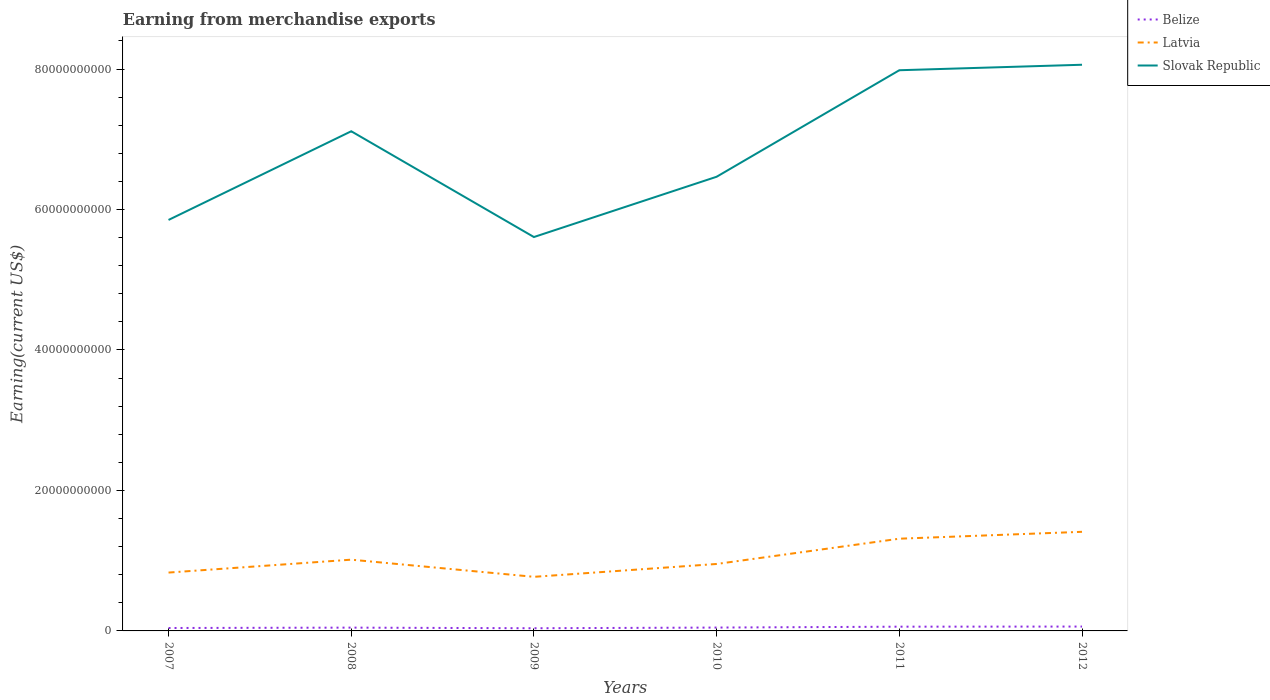How many different coloured lines are there?
Your answer should be very brief. 3. Across all years, what is the maximum amount earned from merchandise exports in Slovak Republic?
Offer a very short reply. 5.61e+1. In which year was the amount earned from merchandise exports in Slovak Republic maximum?
Your answer should be very brief. 2009. What is the total amount earned from merchandise exports in Latvia in the graph?
Your response must be concise. -6.41e+09. What is the difference between the highest and the second highest amount earned from merchandise exports in Slovak Republic?
Your response must be concise. 2.45e+1. How many lines are there?
Make the answer very short. 3. How many years are there in the graph?
Your answer should be very brief. 6. Does the graph contain grids?
Your response must be concise. No. How many legend labels are there?
Provide a short and direct response. 3. What is the title of the graph?
Ensure brevity in your answer.  Earning from merchandise exports. Does "Pakistan" appear as one of the legend labels in the graph?
Your response must be concise. No. What is the label or title of the X-axis?
Your response must be concise. Years. What is the label or title of the Y-axis?
Keep it short and to the point. Earning(current US$). What is the Earning(current US$) of Belize in 2007?
Your response must be concise. 4.16e+08. What is the Earning(current US$) of Latvia in 2007?
Offer a terse response. 8.31e+09. What is the Earning(current US$) of Slovak Republic in 2007?
Your answer should be compact. 5.85e+1. What is the Earning(current US$) of Belize in 2008?
Your answer should be very brief. 4.69e+08. What is the Earning(current US$) in Latvia in 2008?
Your response must be concise. 1.01e+1. What is the Earning(current US$) in Slovak Republic in 2008?
Give a very brief answer. 7.11e+1. What is the Earning(current US$) of Belize in 2009?
Your answer should be very brief. 3.81e+08. What is the Earning(current US$) of Latvia in 2009?
Provide a short and direct response. 7.70e+09. What is the Earning(current US$) in Slovak Republic in 2009?
Keep it short and to the point. 5.61e+1. What is the Earning(current US$) in Belize in 2010?
Give a very brief answer. 4.78e+08. What is the Earning(current US$) of Latvia in 2010?
Ensure brevity in your answer.  9.53e+09. What is the Earning(current US$) of Slovak Republic in 2010?
Your answer should be very brief. 6.47e+1. What is the Earning(current US$) of Belize in 2011?
Provide a short and direct response. 6.04e+08. What is the Earning(current US$) of Latvia in 2011?
Your response must be concise. 1.31e+1. What is the Earning(current US$) in Slovak Republic in 2011?
Make the answer very short. 7.98e+1. What is the Earning(current US$) of Belize in 2012?
Keep it short and to the point. 6.22e+08. What is the Earning(current US$) of Latvia in 2012?
Make the answer very short. 1.41e+1. What is the Earning(current US$) in Slovak Republic in 2012?
Offer a very short reply. 8.06e+1. Across all years, what is the maximum Earning(current US$) of Belize?
Keep it short and to the point. 6.22e+08. Across all years, what is the maximum Earning(current US$) in Latvia?
Your response must be concise. 1.41e+1. Across all years, what is the maximum Earning(current US$) of Slovak Republic?
Ensure brevity in your answer.  8.06e+1. Across all years, what is the minimum Earning(current US$) of Belize?
Give a very brief answer. 3.81e+08. Across all years, what is the minimum Earning(current US$) in Latvia?
Provide a short and direct response. 7.70e+09. Across all years, what is the minimum Earning(current US$) of Slovak Republic?
Your answer should be compact. 5.61e+1. What is the total Earning(current US$) of Belize in the graph?
Provide a succinct answer. 2.97e+09. What is the total Earning(current US$) of Latvia in the graph?
Your response must be concise. 6.29e+1. What is the total Earning(current US$) of Slovak Republic in the graph?
Offer a very short reply. 4.11e+11. What is the difference between the Earning(current US$) in Belize in 2007 and that in 2008?
Provide a succinct answer. -5.28e+07. What is the difference between the Earning(current US$) in Latvia in 2007 and that in 2008?
Keep it short and to the point. -1.84e+09. What is the difference between the Earning(current US$) in Slovak Republic in 2007 and that in 2008?
Provide a succinct answer. -1.26e+1. What is the difference between the Earning(current US$) of Belize in 2007 and that in 2009?
Your response must be concise. 3.54e+07. What is the difference between the Earning(current US$) in Latvia in 2007 and that in 2009?
Keep it short and to the point. 6.06e+08. What is the difference between the Earning(current US$) in Slovak Republic in 2007 and that in 2009?
Offer a very short reply. 2.43e+09. What is the difference between the Earning(current US$) in Belize in 2007 and that in 2010?
Make the answer very short. -6.19e+07. What is the difference between the Earning(current US$) of Latvia in 2007 and that in 2010?
Your response must be concise. -1.22e+09. What is the difference between the Earning(current US$) in Slovak Republic in 2007 and that in 2010?
Offer a very short reply. -6.15e+09. What is the difference between the Earning(current US$) in Belize in 2007 and that in 2011?
Keep it short and to the point. -1.87e+08. What is the difference between the Earning(current US$) in Latvia in 2007 and that in 2011?
Your answer should be very brief. -4.82e+09. What is the difference between the Earning(current US$) in Slovak Republic in 2007 and that in 2011?
Your response must be concise. -2.13e+1. What is the difference between the Earning(current US$) of Belize in 2007 and that in 2012?
Keep it short and to the point. -2.05e+08. What is the difference between the Earning(current US$) in Latvia in 2007 and that in 2012?
Give a very brief answer. -5.80e+09. What is the difference between the Earning(current US$) in Slovak Republic in 2007 and that in 2012?
Make the answer very short. -2.21e+1. What is the difference between the Earning(current US$) in Belize in 2008 and that in 2009?
Provide a short and direct response. 8.82e+07. What is the difference between the Earning(current US$) in Latvia in 2008 and that in 2009?
Provide a succinct answer. 2.44e+09. What is the difference between the Earning(current US$) of Slovak Republic in 2008 and that in 2009?
Your answer should be very brief. 1.51e+1. What is the difference between the Earning(current US$) of Belize in 2008 and that in 2010?
Give a very brief answer. -9.06e+06. What is the difference between the Earning(current US$) of Latvia in 2008 and that in 2010?
Offer a terse response. 6.12e+08. What is the difference between the Earning(current US$) in Slovak Republic in 2008 and that in 2010?
Make the answer very short. 6.48e+09. What is the difference between the Earning(current US$) of Belize in 2008 and that in 2011?
Keep it short and to the point. -1.34e+08. What is the difference between the Earning(current US$) in Latvia in 2008 and that in 2011?
Keep it short and to the point. -2.99e+09. What is the difference between the Earning(current US$) in Slovak Republic in 2008 and that in 2011?
Offer a terse response. -8.69e+09. What is the difference between the Earning(current US$) of Belize in 2008 and that in 2012?
Provide a succinct answer. -1.52e+08. What is the difference between the Earning(current US$) of Latvia in 2008 and that in 2012?
Offer a very short reply. -3.97e+09. What is the difference between the Earning(current US$) in Slovak Republic in 2008 and that in 2012?
Provide a succinct answer. -9.47e+09. What is the difference between the Earning(current US$) of Belize in 2009 and that in 2010?
Provide a short and direct response. -9.72e+07. What is the difference between the Earning(current US$) of Latvia in 2009 and that in 2010?
Offer a terse response. -1.83e+09. What is the difference between the Earning(current US$) in Slovak Republic in 2009 and that in 2010?
Provide a succinct answer. -8.58e+09. What is the difference between the Earning(current US$) in Belize in 2009 and that in 2011?
Your answer should be compact. -2.23e+08. What is the difference between the Earning(current US$) of Latvia in 2009 and that in 2011?
Give a very brief answer. -5.43e+09. What is the difference between the Earning(current US$) in Slovak Republic in 2009 and that in 2011?
Give a very brief answer. -2.37e+1. What is the difference between the Earning(current US$) of Belize in 2009 and that in 2012?
Your answer should be compact. -2.41e+08. What is the difference between the Earning(current US$) of Latvia in 2009 and that in 2012?
Give a very brief answer. -6.41e+09. What is the difference between the Earning(current US$) of Slovak Republic in 2009 and that in 2012?
Give a very brief answer. -2.45e+1. What is the difference between the Earning(current US$) of Belize in 2010 and that in 2011?
Keep it short and to the point. -1.25e+08. What is the difference between the Earning(current US$) of Latvia in 2010 and that in 2011?
Make the answer very short. -3.60e+09. What is the difference between the Earning(current US$) in Slovak Republic in 2010 and that in 2011?
Keep it short and to the point. -1.52e+1. What is the difference between the Earning(current US$) of Belize in 2010 and that in 2012?
Give a very brief answer. -1.43e+08. What is the difference between the Earning(current US$) in Latvia in 2010 and that in 2012?
Make the answer very short. -4.58e+09. What is the difference between the Earning(current US$) of Slovak Republic in 2010 and that in 2012?
Offer a very short reply. -1.59e+1. What is the difference between the Earning(current US$) of Belize in 2011 and that in 2012?
Provide a short and direct response. -1.80e+07. What is the difference between the Earning(current US$) in Latvia in 2011 and that in 2012?
Your response must be concise. -9.81e+08. What is the difference between the Earning(current US$) in Slovak Republic in 2011 and that in 2012?
Your answer should be compact. -7.81e+08. What is the difference between the Earning(current US$) of Belize in 2007 and the Earning(current US$) of Latvia in 2008?
Provide a short and direct response. -9.73e+09. What is the difference between the Earning(current US$) in Belize in 2007 and the Earning(current US$) in Slovak Republic in 2008?
Ensure brevity in your answer.  -7.07e+1. What is the difference between the Earning(current US$) in Latvia in 2007 and the Earning(current US$) in Slovak Republic in 2008?
Ensure brevity in your answer.  -6.28e+1. What is the difference between the Earning(current US$) of Belize in 2007 and the Earning(current US$) of Latvia in 2009?
Your answer should be compact. -7.29e+09. What is the difference between the Earning(current US$) in Belize in 2007 and the Earning(current US$) in Slovak Republic in 2009?
Make the answer very short. -5.57e+1. What is the difference between the Earning(current US$) of Latvia in 2007 and the Earning(current US$) of Slovak Republic in 2009?
Give a very brief answer. -4.78e+1. What is the difference between the Earning(current US$) of Belize in 2007 and the Earning(current US$) of Latvia in 2010?
Provide a short and direct response. -9.12e+09. What is the difference between the Earning(current US$) of Belize in 2007 and the Earning(current US$) of Slovak Republic in 2010?
Provide a short and direct response. -6.42e+1. What is the difference between the Earning(current US$) in Latvia in 2007 and the Earning(current US$) in Slovak Republic in 2010?
Provide a short and direct response. -5.64e+1. What is the difference between the Earning(current US$) in Belize in 2007 and the Earning(current US$) in Latvia in 2011?
Offer a very short reply. -1.27e+1. What is the difference between the Earning(current US$) in Belize in 2007 and the Earning(current US$) in Slovak Republic in 2011?
Give a very brief answer. -7.94e+1. What is the difference between the Earning(current US$) of Latvia in 2007 and the Earning(current US$) of Slovak Republic in 2011?
Keep it short and to the point. -7.15e+1. What is the difference between the Earning(current US$) of Belize in 2007 and the Earning(current US$) of Latvia in 2012?
Provide a succinct answer. -1.37e+1. What is the difference between the Earning(current US$) of Belize in 2007 and the Earning(current US$) of Slovak Republic in 2012?
Provide a short and direct response. -8.02e+1. What is the difference between the Earning(current US$) in Latvia in 2007 and the Earning(current US$) in Slovak Republic in 2012?
Your response must be concise. -7.23e+1. What is the difference between the Earning(current US$) in Belize in 2008 and the Earning(current US$) in Latvia in 2009?
Your answer should be very brief. -7.23e+09. What is the difference between the Earning(current US$) of Belize in 2008 and the Earning(current US$) of Slovak Republic in 2009?
Your answer should be very brief. -5.56e+1. What is the difference between the Earning(current US$) of Latvia in 2008 and the Earning(current US$) of Slovak Republic in 2009?
Your answer should be compact. -4.59e+1. What is the difference between the Earning(current US$) of Belize in 2008 and the Earning(current US$) of Latvia in 2010?
Your response must be concise. -9.06e+09. What is the difference between the Earning(current US$) of Belize in 2008 and the Earning(current US$) of Slovak Republic in 2010?
Ensure brevity in your answer.  -6.42e+1. What is the difference between the Earning(current US$) of Latvia in 2008 and the Earning(current US$) of Slovak Republic in 2010?
Your answer should be compact. -5.45e+1. What is the difference between the Earning(current US$) of Belize in 2008 and the Earning(current US$) of Latvia in 2011?
Make the answer very short. -1.27e+1. What is the difference between the Earning(current US$) of Belize in 2008 and the Earning(current US$) of Slovak Republic in 2011?
Your answer should be very brief. -7.94e+1. What is the difference between the Earning(current US$) of Latvia in 2008 and the Earning(current US$) of Slovak Republic in 2011?
Make the answer very short. -6.97e+1. What is the difference between the Earning(current US$) in Belize in 2008 and the Earning(current US$) in Latvia in 2012?
Make the answer very short. -1.36e+1. What is the difference between the Earning(current US$) in Belize in 2008 and the Earning(current US$) in Slovak Republic in 2012?
Keep it short and to the point. -8.01e+1. What is the difference between the Earning(current US$) in Latvia in 2008 and the Earning(current US$) in Slovak Republic in 2012?
Provide a short and direct response. -7.05e+1. What is the difference between the Earning(current US$) of Belize in 2009 and the Earning(current US$) of Latvia in 2010?
Provide a succinct answer. -9.15e+09. What is the difference between the Earning(current US$) in Belize in 2009 and the Earning(current US$) in Slovak Republic in 2010?
Make the answer very short. -6.43e+1. What is the difference between the Earning(current US$) of Latvia in 2009 and the Earning(current US$) of Slovak Republic in 2010?
Give a very brief answer. -5.70e+1. What is the difference between the Earning(current US$) of Belize in 2009 and the Earning(current US$) of Latvia in 2011?
Provide a succinct answer. -1.27e+1. What is the difference between the Earning(current US$) in Belize in 2009 and the Earning(current US$) in Slovak Republic in 2011?
Offer a very short reply. -7.94e+1. What is the difference between the Earning(current US$) of Latvia in 2009 and the Earning(current US$) of Slovak Republic in 2011?
Your answer should be very brief. -7.21e+1. What is the difference between the Earning(current US$) of Belize in 2009 and the Earning(current US$) of Latvia in 2012?
Offer a very short reply. -1.37e+1. What is the difference between the Earning(current US$) in Belize in 2009 and the Earning(current US$) in Slovak Republic in 2012?
Ensure brevity in your answer.  -8.02e+1. What is the difference between the Earning(current US$) of Latvia in 2009 and the Earning(current US$) of Slovak Republic in 2012?
Provide a short and direct response. -7.29e+1. What is the difference between the Earning(current US$) in Belize in 2010 and the Earning(current US$) in Latvia in 2011?
Keep it short and to the point. -1.27e+1. What is the difference between the Earning(current US$) of Belize in 2010 and the Earning(current US$) of Slovak Republic in 2011?
Make the answer very short. -7.94e+1. What is the difference between the Earning(current US$) of Latvia in 2010 and the Earning(current US$) of Slovak Republic in 2011?
Offer a very short reply. -7.03e+1. What is the difference between the Earning(current US$) in Belize in 2010 and the Earning(current US$) in Latvia in 2012?
Your answer should be very brief. -1.36e+1. What is the difference between the Earning(current US$) in Belize in 2010 and the Earning(current US$) in Slovak Republic in 2012?
Give a very brief answer. -8.01e+1. What is the difference between the Earning(current US$) of Latvia in 2010 and the Earning(current US$) of Slovak Republic in 2012?
Your answer should be very brief. -7.11e+1. What is the difference between the Earning(current US$) of Belize in 2011 and the Earning(current US$) of Latvia in 2012?
Make the answer very short. -1.35e+1. What is the difference between the Earning(current US$) of Belize in 2011 and the Earning(current US$) of Slovak Republic in 2012?
Provide a succinct answer. -8.00e+1. What is the difference between the Earning(current US$) in Latvia in 2011 and the Earning(current US$) in Slovak Republic in 2012?
Give a very brief answer. -6.75e+1. What is the average Earning(current US$) in Belize per year?
Your answer should be compact. 4.95e+08. What is the average Earning(current US$) of Latvia per year?
Your response must be concise. 1.05e+1. What is the average Earning(current US$) in Slovak Republic per year?
Provide a succinct answer. 6.85e+1. In the year 2007, what is the difference between the Earning(current US$) of Belize and Earning(current US$) of Latvia?
Keep it short and to the point. -7.89e+09. In the year 2007, what is the difference between the Earning(current US$) of Belize and Earning(current US$) of Slovak Republic?
Provide a short and direct response. -5.81e+1. In the year 2007, what is the difference between the Earning(current US$) of Latvia and Earning(current US$) of Slovak Republic?
Your answer should be compact. -5.02e+1. In the year 2008, what is the difference between the Earning(current US$) of Belize and Earning(current US$) of Latvia?
Offer a terse response. -9.68e+09. In the year 2008, what is the difference between the Earning(current US$) of Belize and Earning(current US$) of Slovak Republic?
Your response must be concise. -7.07e+1. In the year 2008, what is the difference between the Earning(current US$) of Latvia and Earning(current US$) of Slovak Republic?
Your answer should be compact. -6.10e+1. In the year 2009, what is the difference between the Earning(current US$) in Belize and Earning(current US$) in Latvia?
Keep it short and to the point. -7.32e+09. In the year 2009, what is the difference between the Earning(current US$) of Belize and Earning(current US$) of Slovak Republic?
Your answer should be very brief. -5.57e+1. In the year 2009, what is the difference between the Earning(current US$) of Latvia and Earning(current US$) of Slovak Republic?
Provide a short and direct response. -4.84e+1. In the year 2010, what is the difference between the Earning(current US$) in Belize and Earning(current US$) in Latvia?
Keep it short and to the point. -9.05e+09. In the year 2010, what is the difference between the Earning(current US$) in Belize and Earning(current US$) in Slovak Republic?
Keep it short and to the point. -6.42e+1. In the year 2010, what is the difference between the Earning(current US$) of Latvia and Earning(current US$) of Slovak Republic?
Your answer should be compact. -5.51e+1. In the year 2011, what is the difference between the Earning(current US$) of Belize and Earning(current US$) of Latvia?
Provide a short and direct response. -1.25e+1. In the year 2011, what is the difference between the Earning(current US$) in Belize and Earning(current US$) in Slovak Republic?
Make the answer very short. -7.92e+1. In the year 2011, what is the difference between the Earning(current US$) of Latvia and Earning(current US$) of Slovak Republic?
Keep it short and to the point. -6.67e+1. In the year 2012, what is the difference between the Earning(current US$) of Belize and Earning(current US$) of Latvia?
Your answer should be very brief. -1.35e+1. In the year 2012, what is the difference between the Earning(current US$) of Belize and Earning(current US$) of Slovak Republic?
Give a very brief answer. -8.00e+1. In the year 2012, what is the difference between the Earning(current US$) of Latvia and Earning(current US$) of Slovak Republic?
Your response must be concise. -6.65e+1. What is the ratio of the Earning(current US$) in Belize in 2007 to that in 2008?
Your answer should be compact. 0.89. What is the ratio of the Earning(current US$) of Latvia in 2007 to that in 2008?
Make the answer very short. 0.82. What is the ratio of the Earning(current US$) in Slovak Republic in 2007 to that in 2008?
Your answer should be compact. 0.82. What is the ratio of the Earning(current US$) in Belize in 2007 to that in 2009?
Your response must be concise. 1.09. What is the ratio of the Earning(current US$) of Latvia in 2007 to that in 2009?
Offer a terse response. 1.08. What is the ratio of the Earning(current US$) in Slovak Republic in 2007 to that in 2009?
Offer a very short reply. 1.04. What is the ratio of the Earning(current US$) in Belize in 2007 to that in 2010?
Provide a succinct answer. 0.87. What is the ratio of the Earning(current US$) of Latvia in 2007 to that in 2010?
Provide a short and direct response. 0.87. What is the ratio of the Earning(current US$) of Slovak Republic in 2007 to that in 2010?
Your answer should be compact. 0.9. What is the ratio of the Earning(current US$) in Belize in 2007 to that in 2011?
Give a very brief answer. 0.69. What is the ratio of the Earning(current US$) in Latvia in 2007 to that in 2011?
Give a very brief answer. 0.63. What is the ratio of the Earning(current US$) of Slovak Republic in 2007 to that in 2011?
Make the answer very short. 0.73. What is the ratio of the Earning(current US$) of Belize in 2007 to that in 2012?
Keep it short and to the point. 0.67. What is the ratio of the Earning(current US$) of Latvia in 2007 to that in 2012?
Provide a short and direct response. 0.59. What is the ratio of the Earning(current US$) in Slovak Republic in 2007 to that in 2012?
Provide a succinct answer. 0.73. What is the ratio of the Earning(current US$) of Belize in 2008 to that in 2009?
Offer a very short reply. 1.23. What is the ratio of the Earning(current US$) in Latvia in 2008 to that in 2009?
Keep it short and to the point. 1.32. What is the ratio of the Earning(current US$) in Slovak Republic in 2008 to that in 2009?
Make the answer very short. 1.27. What is the ratio of the Earning(current US$) of Latvia in 2008 to that in 2010?
Your answer should be very brief. 1.06. What is the ratio of the Earning(current US$) in Slovak Republic in 2008 to that in 2010?
Provide a short and direct response. 1.1. What is the ratio of the Earning(current US$) in Belize in 2008 to that in 2011?
Your answer should be very brief. 0.78. What is the ratio of the Earning(current US$) in Latvia in 2008 to that in 2011?
Provide a short and direct response. 0.77. What is the ratio of the Earning(current US$) in Slovak Republic in 2008 to that in 2011?
Give a very brief answer. 0.89. What is the ratio of the Earning(current US$) in Belize in 2008 to that in 2012?
Keep it short and to the point. 0.75. What is the ratio of the Earning(current US$) of Latvia in 2008 to that in 2012?
Keep it short and to the point. 0.72. What is the ratio of the Earning(current US$) of Slovak Republic in 2008 to that in 2012?
Offer a terse response. 0.88. What is the ratio of the Earning(current US$) of Belize in 2009 to that in 2010?
Make the answer very short. 0.8. What is the ratio of the Earning(current US$) of Latvia in 2009 to that in 2010?
Offer a terse response. 0.81. What is the ratio of the Earning(current US$) in Slovak Republic in 2009 to that in 2010?
Make the answer very short. 0.87. What is the ratio of the Earning(current US$) in Belize in 2009 to that in 2011?
Provide a short and direct response. 0.63. What is the ratio of the Earning(current US$) in Latvia in 2009 to that in 2011?
Your answer should be compact. 0.59. What is the ratio of the Earning(current US$) in Slovak Republic in 2009 to that in 2011?
Your answer should be very brief. 0.7. What is the ratio of the Earning(current US$) in Belize in 2009 to that in 2012?
Your answer should be compact. 0.61. What is the ratio of the Earning(current US$) of Latvia in 2009 to that in 2012?
Provide a short and direct response. 0.55. What is the ratio of the Earning(current US$) of Slovak Republic in 2009 to that in 2012?
Provide a short and direct response. 0.7. What is the ratio of the Earning(current US$) in Belize in 2010 to that in 2011?
Your answer should be very brief. 0.79. What is the ratio of the Earning(current US$) in Latvia in 2010 to that in 2011?
Offer a very short reply. 0.73. What is the ratio of the Earning(current US$) in Slovak Republic in 2010 to that in 2011?
Your answer should be very brief. 0.81. What is the ratio of the Earning(current US$) of Belize in 2010 to that in 2012?
Make the answer very short. 0.77. What is the ratio of the Earning(current US$) in Latvia in 2010 to that in 2012?
Keep it short and to the point. 0.68. What is the ratio of the Earning(current US$) in Slovak Republic in 2010 to that in 2012?
Provide a short and direct response. 0.8. What is the ratio of the Earning(current US$) in Belize in 2011 to that in 2012?
Make the answer very short. 0.97. What is the ratio of the Earning(current US$) in Latvia in 2011 to that in 2012?
Your answer should be very brief. 0.93. What is the ratio of the Earning(current US$) of Slovak Republic in 2011 to that in 2012?
Keep it short and to the point. 0.99. What is the difference between the highest and the second highest Earning(current US$) of Belize?
Your answer should be compact. 1.80e+07. What is the difference between the highest and the second highest Earning(current US$) in Latvia?
Your response must be concise. 9.81e+08. What is the difference between the highest and the second highest Earning(current US$) in Slovak Republic?
Provide a succinct answer. 7.81e+08. What is the difference between the highest and the lowest Earning(current US$) in Belize?
Your answer should be compact. 2.41e+08. What is the difference between the highest and the lowest Earning(current US$) in Latvia?
Your answer should be compact. 6.41e+09. What is the difference between the highest and the lowest Earning(current US$) in Slovak Republic?
Offer a terse response. 2.45e+1. 